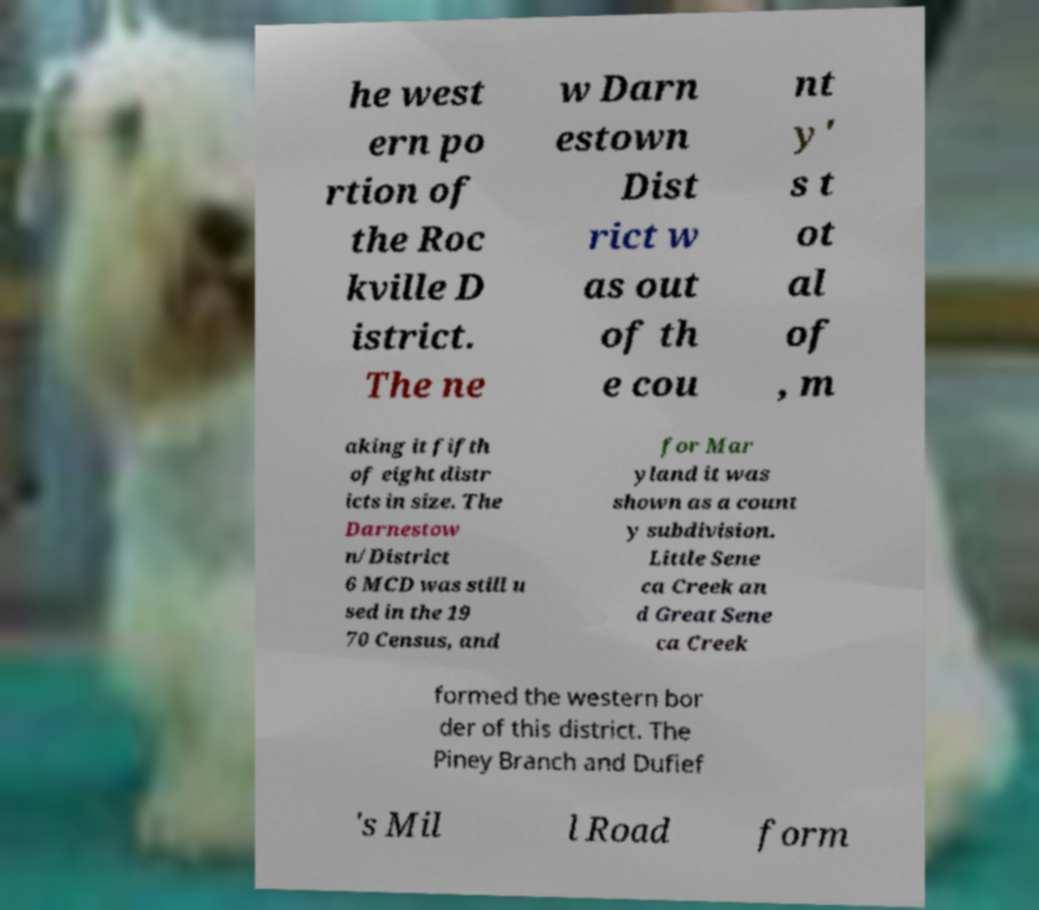What messages or text are displayed in this image? I need them in a readable, typed format. he west ern po rtion of the Roc kville D istrict. The ne w Darn estown Dist rict w as out of th e cou nt y' s t ot al of , m aking it fifth of eight distr icts in size. The Darnestow n/District 6 MCD was still u sed in the 19 70 Census, and for Mar yland it was shown as a count y subdivision. Little Sene ca Creek an d Great Sene ca Creek formed the western bor der of this district. The Piney Branch and Dufief 's Mil l Road form 